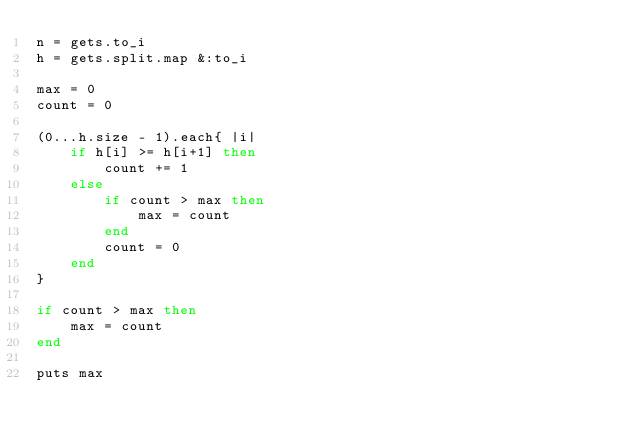Convert code to text. <code><loc_0><loc_0><loc_500><loc_500><_Ruby_>n = gets.to_i
h = gets.split.map &:to_i

max = 0
count = 0

(0...h.size - 1).each{ |i|
	if h[i] >= h[i+1] then
		count += 1
	else
		if count > max then
			max = count
		end
		count = 0
	end
}

if count > max then
	max = count
end

puts max
</code> 